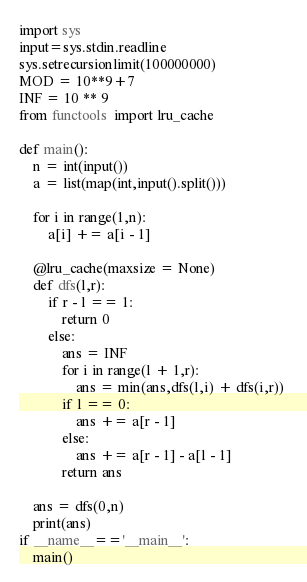<code> <loc_0><loc_0><loc_500><loc_500><_Python_>import sys
input=sys.stdin.readline
sys.setrecursionlimit(100000000)
MOD = 10**9+7
INF = 10 ** 9
from functools  import lru_cache

def main():
    n = int(input())
    a = list(map(int,input().split()))

    for i in range(1,n):
        a[i] += a[i - 1]
    
    @lru_cache(maxsize = None)
    def dfs(l,r):
        if r - l == 1:
            return 0
        else:
            ans = INF
            for i in range(l + 1,r):
                ans = min(ans,dfs(l,i) + dfs(i,r)) 
            if l == 0:
                ans += a[r - 1]
            else:
                ans += a[r - 1] - a[l - 1]
            return ans
    
    ans = dfs(0,n)
    print(ans)
if __name__=='__main__':
    main()</code> 